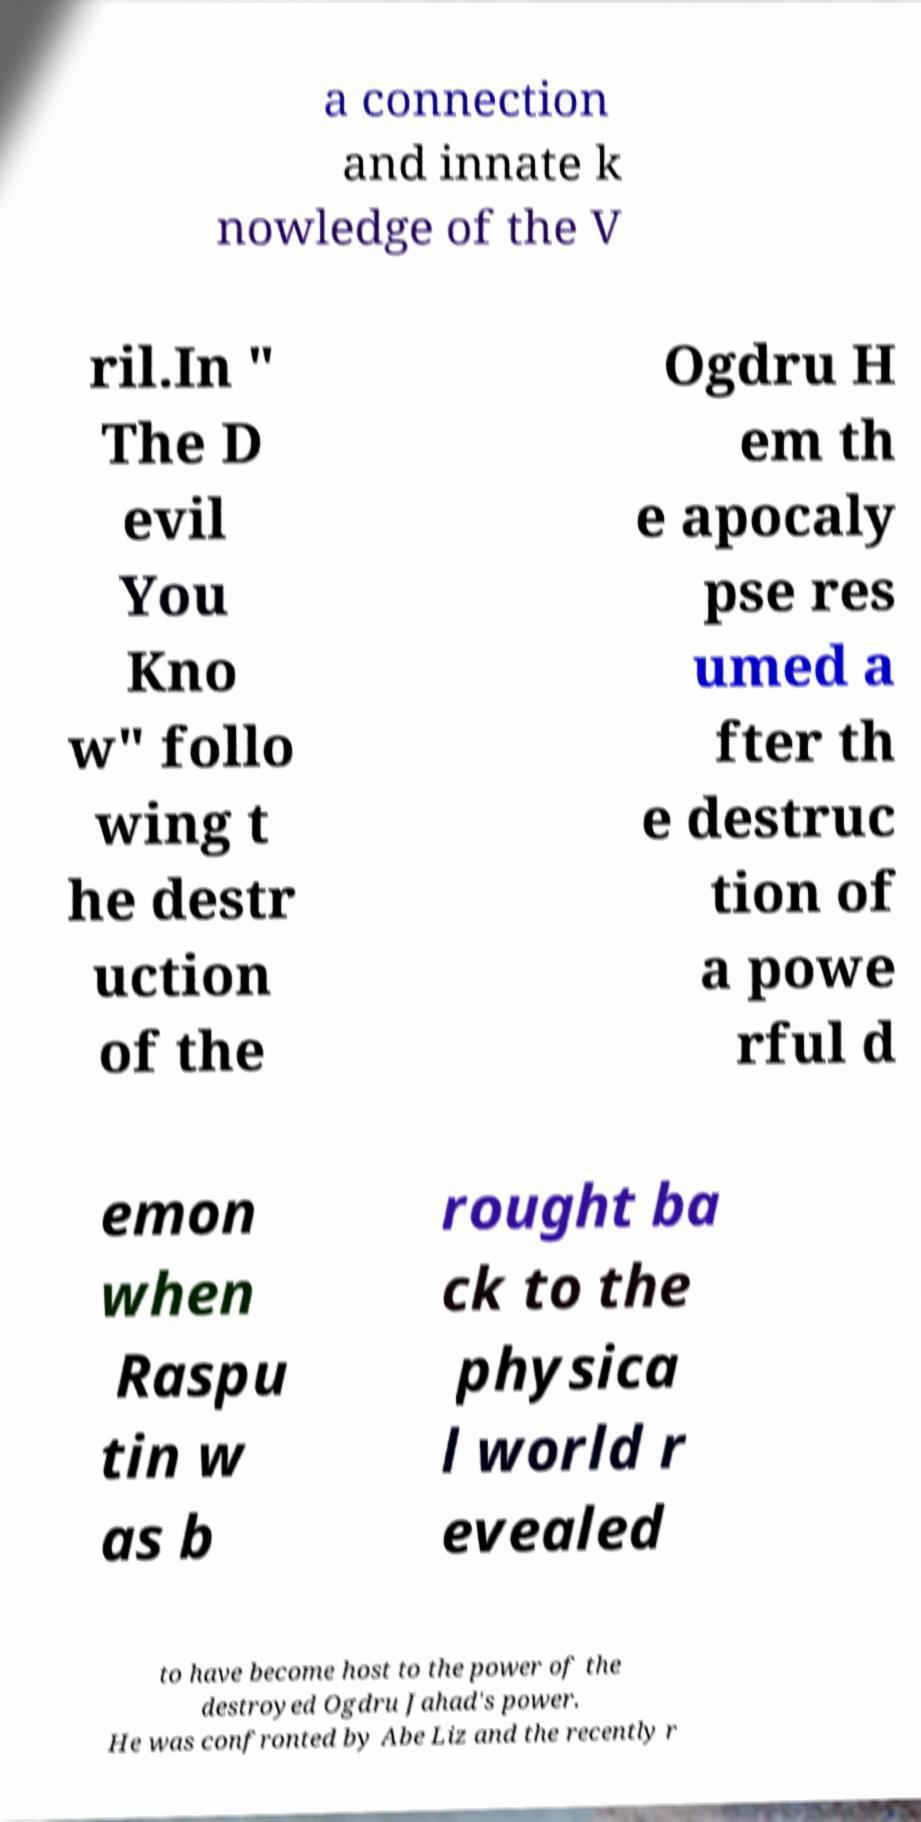For documentation purposes, I need the text within this image transcribed. Could you provide that? a connection and innate k nowledge of the V ril.In " The D evil You Kno w" follo wing t he destr uction of the Ogdru H em th e apocaly pse res umed a fter th e destruc tion of a powe rful d emon when Raspu tin w as b rought ba ck to the physica l world r evealed to have become host to the power of the destroyed Ogdru Jahad's power. He was confronted by Abe Liz and the recently r 